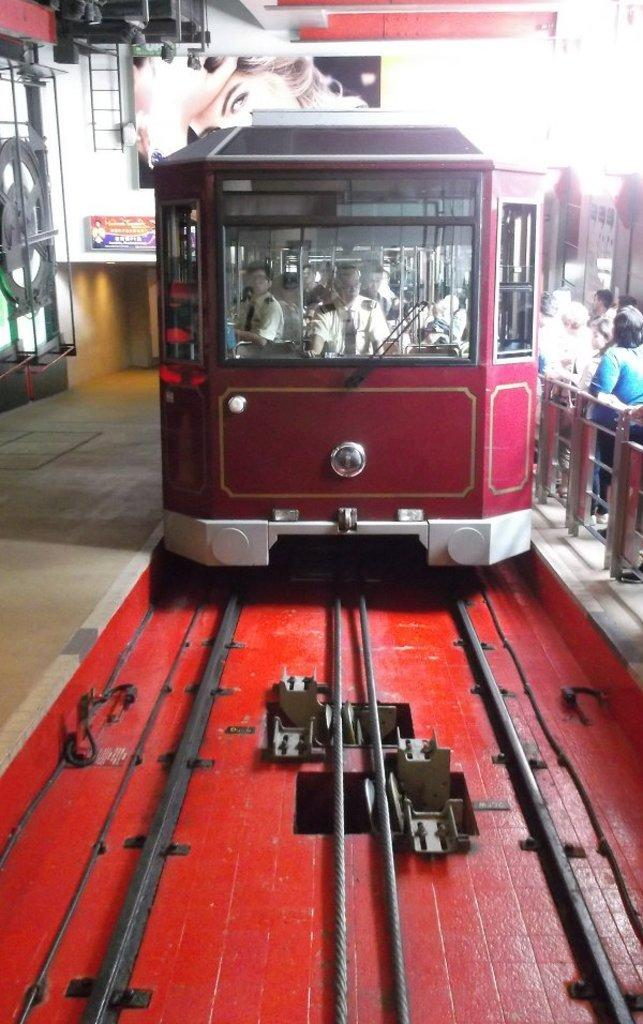What is the main subject of the image? The main subject of the image is a train. Can you describe the train's appearance? The train is red in color. What is located at the bottom of the image? There are railway tracks at the bottom of the image. Are there any people visible in the image? Yes, there are some persons on the right side of the image. What type of voyage is the train embarking on in the image? There is no indication of a voyage in the image; it simply shows a red train and some persons on the right side. What adjustments are being made to the train in the image? There are no adjustments being made to the train in the image; it appears to be stationary on the railway tracks. 